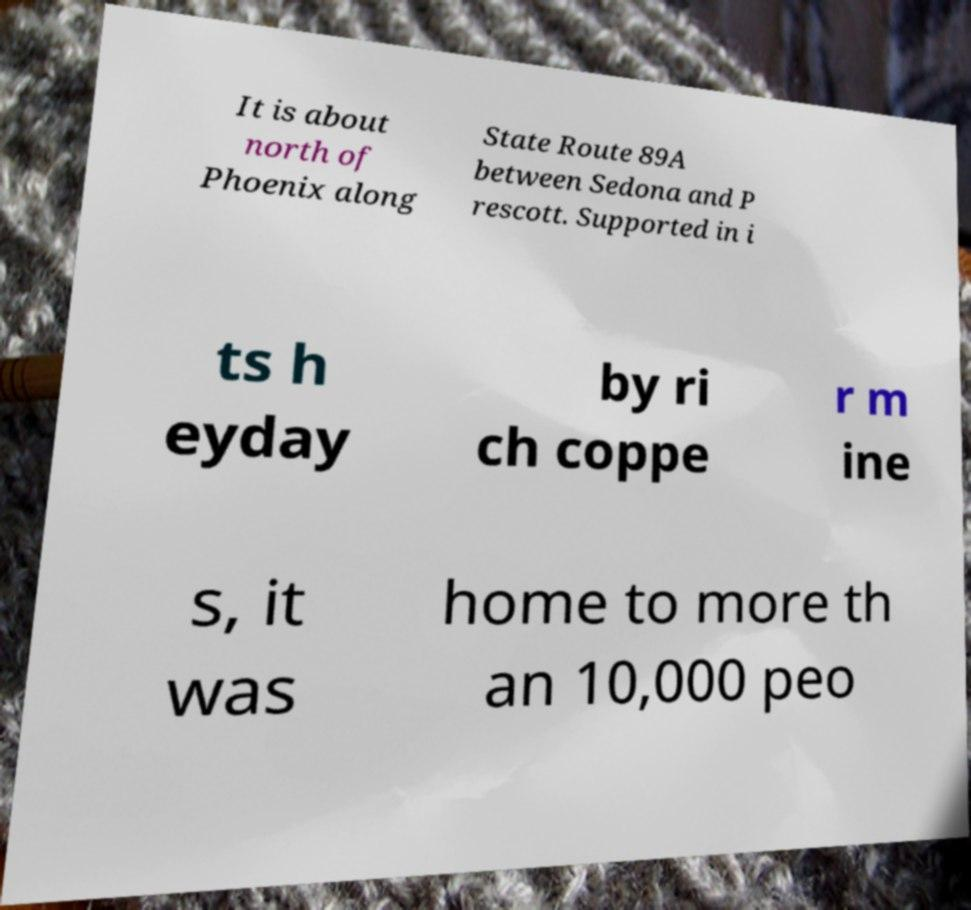Please read and relay the text visible in this image. What does it say? It is about north of Phoenix along State Route 89A between Sedona and P rescott. Supported in i ts h eyday by ri ch coppe r m ine s, it was home to more th an 10,000 peo 